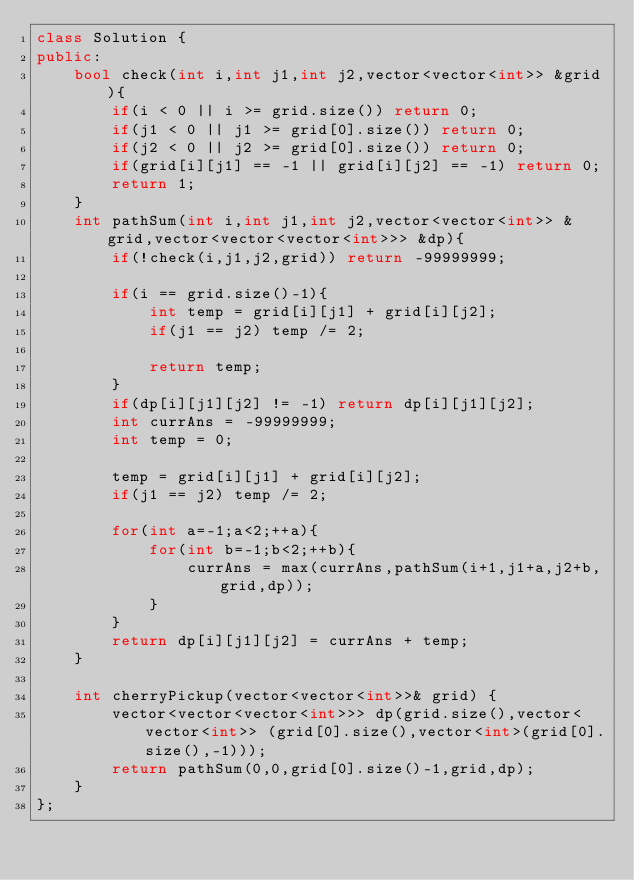<code> <loc_0><loc_0><loc_500><loc_500><_C++_>class Solution {
public:
    bool check(int i,int j1,int j2,vector<vector<int>> &grid){
        if(i < 0 || i >= grid.size()) return 0;
        if(j1 < 0 || j1 >= grid[0].size()) return 0;
        if(j2 < 0 || j2 >= grid[0].size()) return 0;
        if(grid[i][j1] == -1 || grid[i][j2] == -1) return 0;
        return 1;
    }
    int pathSum(int i,int j1,int j2,vector<vector<int>> &grid,vector<vector<vector<int>>> &dp){
        if(!check(i,j1,j2,grid)) return -99999999;
        
        if(i == grid.size()-1){
            int temp = grid[i][j1] + grid[i][j2];
            if(j1 == j2) temp /= 2;
            
            return temp;
        }
        if(dp[i][j1][j2] != -1) return dp[i][j1][j2];
        int currAns = -99999999;
        int temp = 0;
        
        temp = grid[i][j1] + grid[i][j2];
        if(j1 == j2) temp /= 2;
        
        for(int a=-1;a<2;++a){
            for(int b=-1;b<2;++b){
                currAns = max(currAns,pathSum(i+1,j1+a,j2+b,grid,dp));
            }
        }
        return dp[i][j1][j2] = currAns + temp;
    }
    
    int cherryPickup(vector<vector<int>>& grid) {
        vector<vector<vector<int>>> dp(grid.size(),vector<vector<int>> (grid[0].size(),vector<int>(grid[0].size(),-1)));
        return pathSum(0,0,grid[0].size()-1,grid,dp);
    }
};</code> 